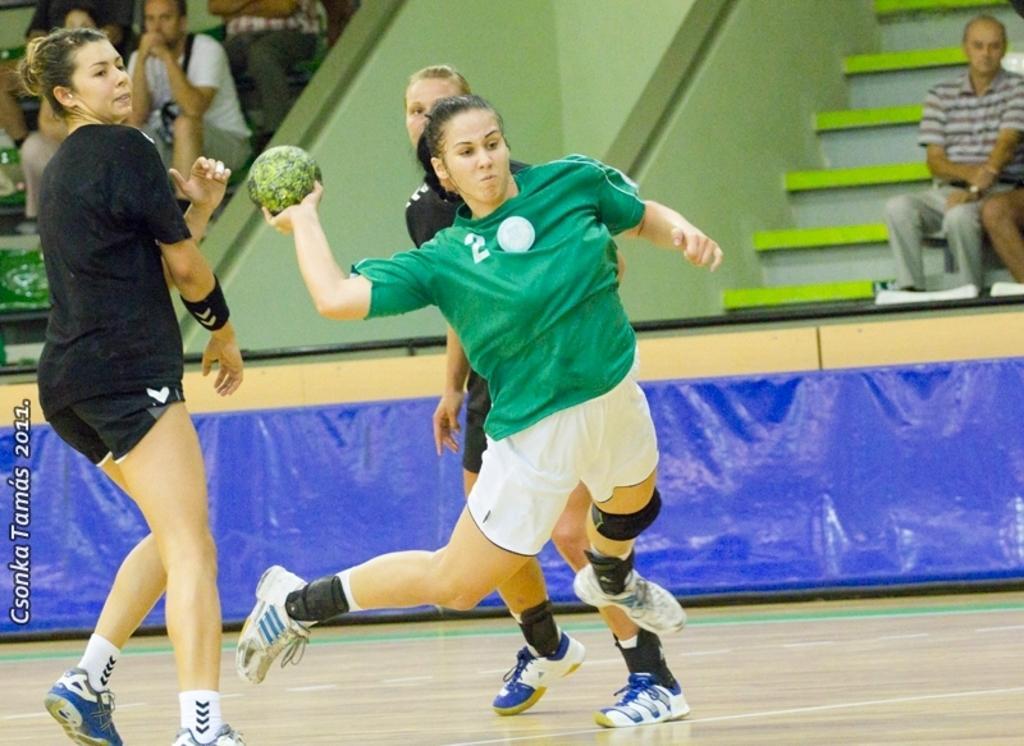Can you describe this image briefly? In this image there are players playing on a court, in the background there are people sitting on benches, in the bottom left there is text. 